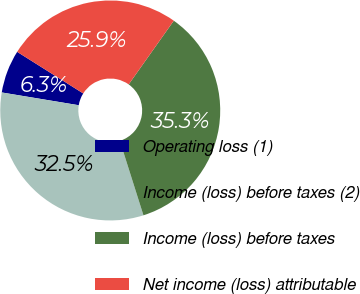Convert chart to OTSL. <chart><loc_0><loc_0><loc_500><loc_500><pie_chart><fcel>Operating loss (1)<fcel>Income (loss) before taxes (2)<fcel>Income (loss) before taxes<fcel>Net income (loss) attributable<nl><fcel>6.33%<fcel>32.5%<fcel>35.31%<fcel>25.86%<nl></chart> 